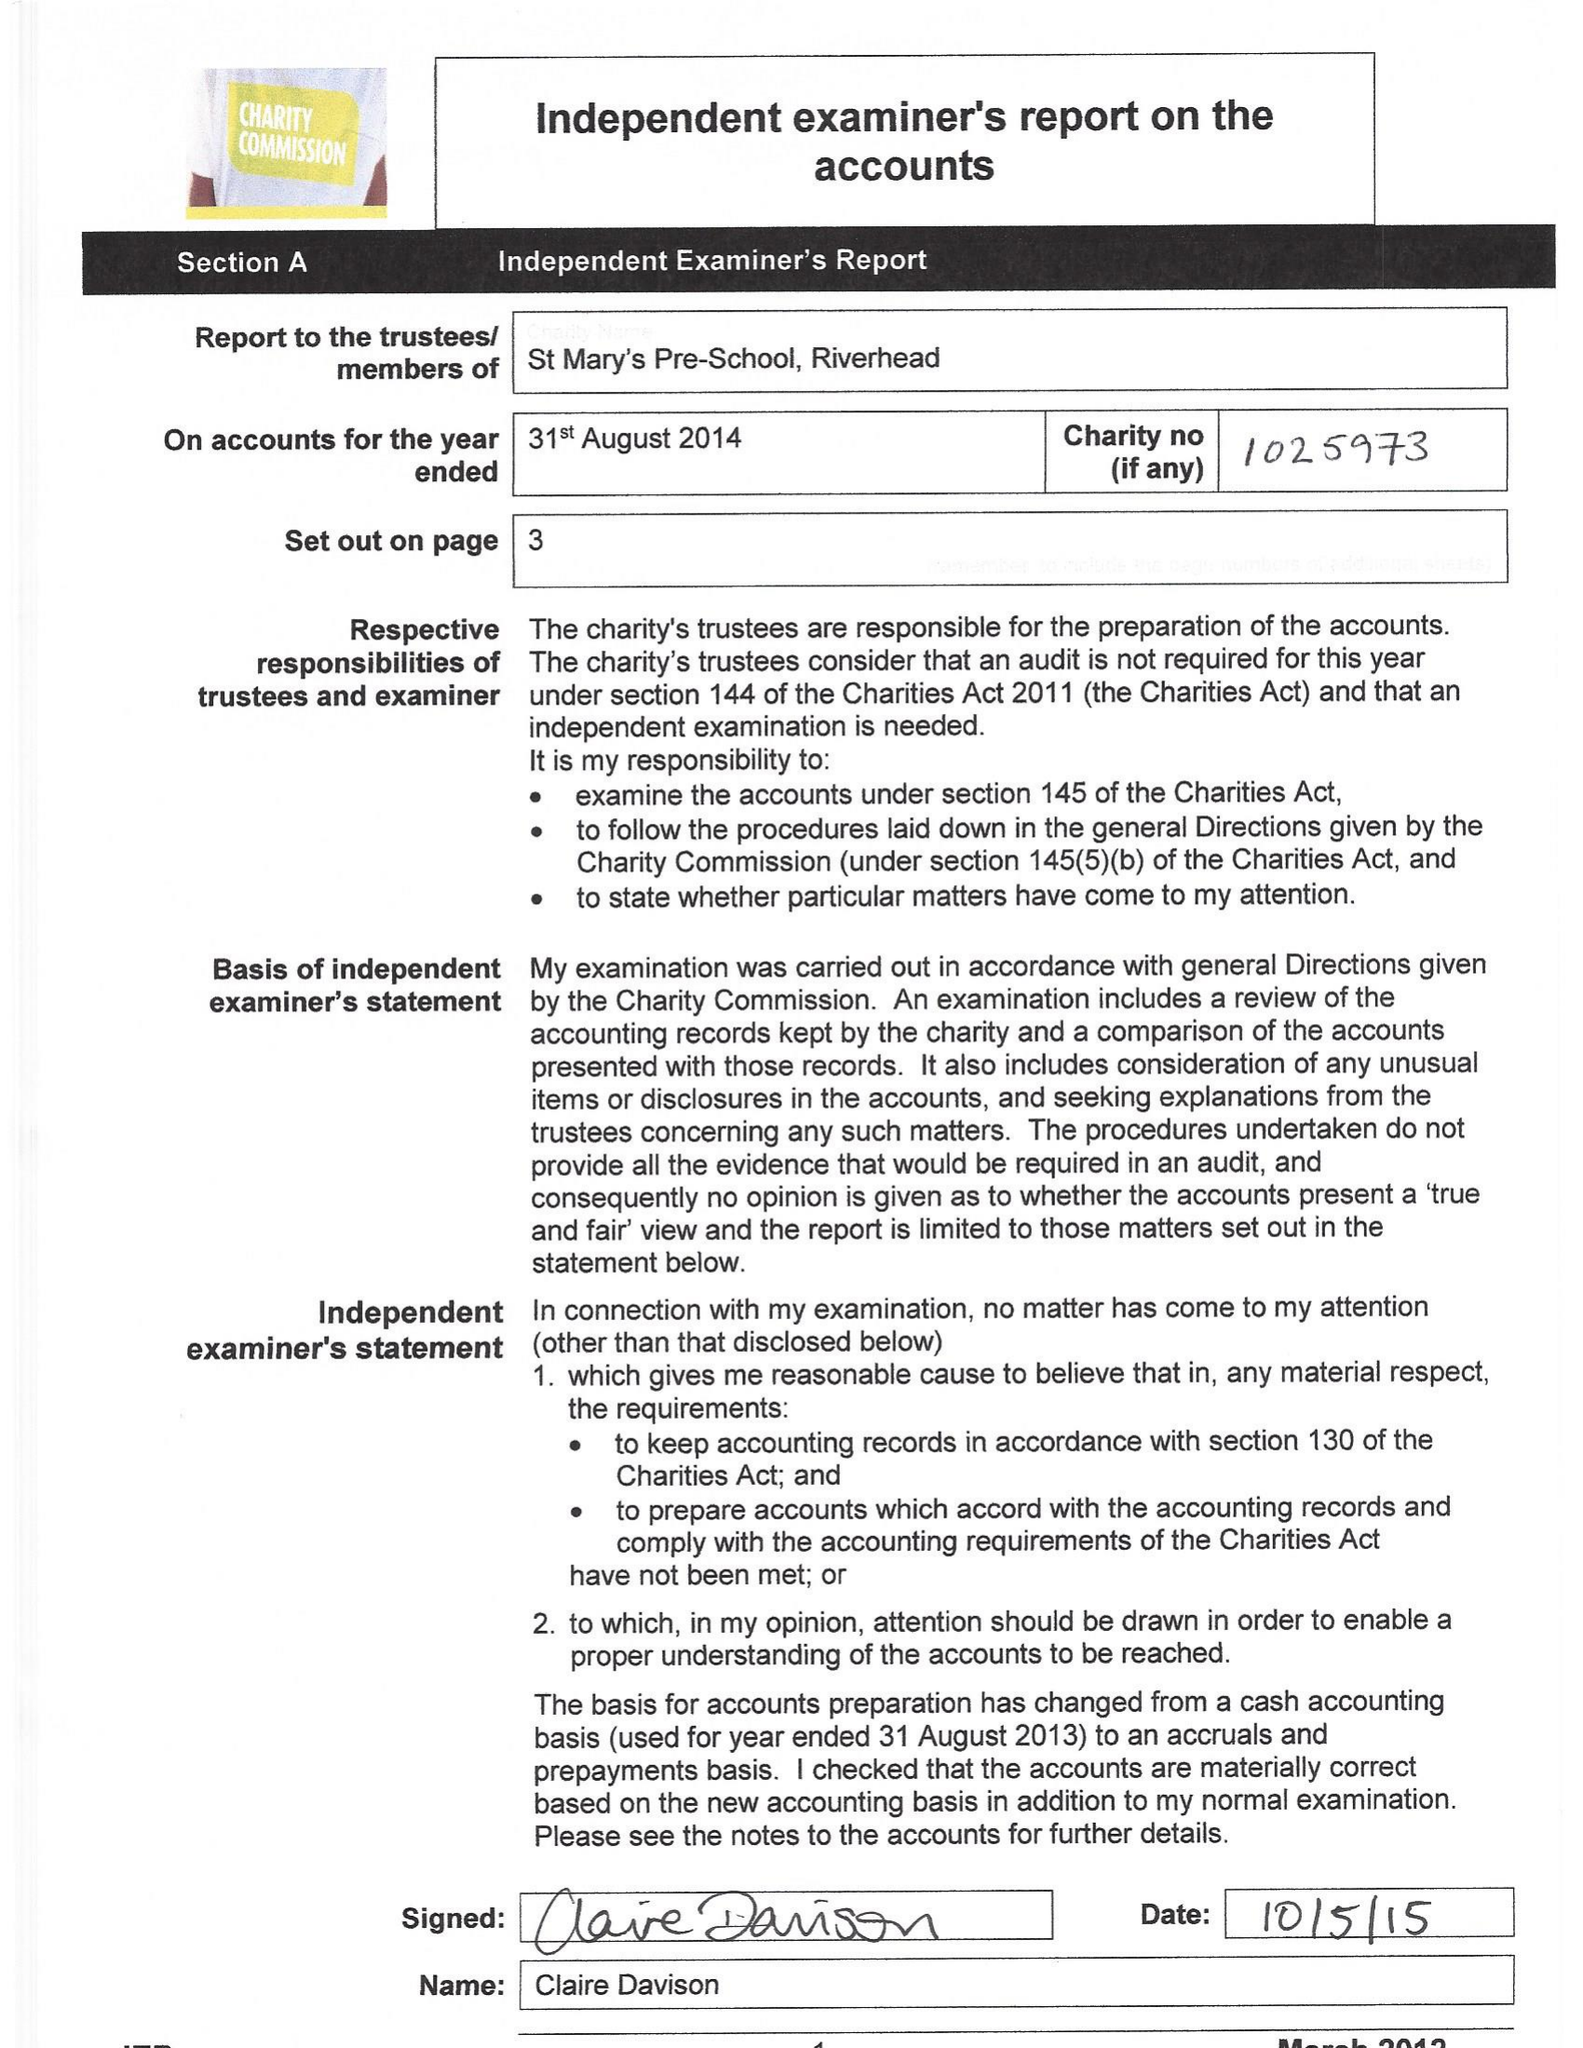What is the value for the address__street_line?
Answer the question using a single word or phrase. 8 LEONARD AVENUE 